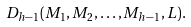<formula> <loc_0><loc_0><loc_500><loc_500>D _ { h - 1 } ( M _ { 1 } , M _ { 2 } , \dots , M _ { h - 1 } , L ) .</formula> 